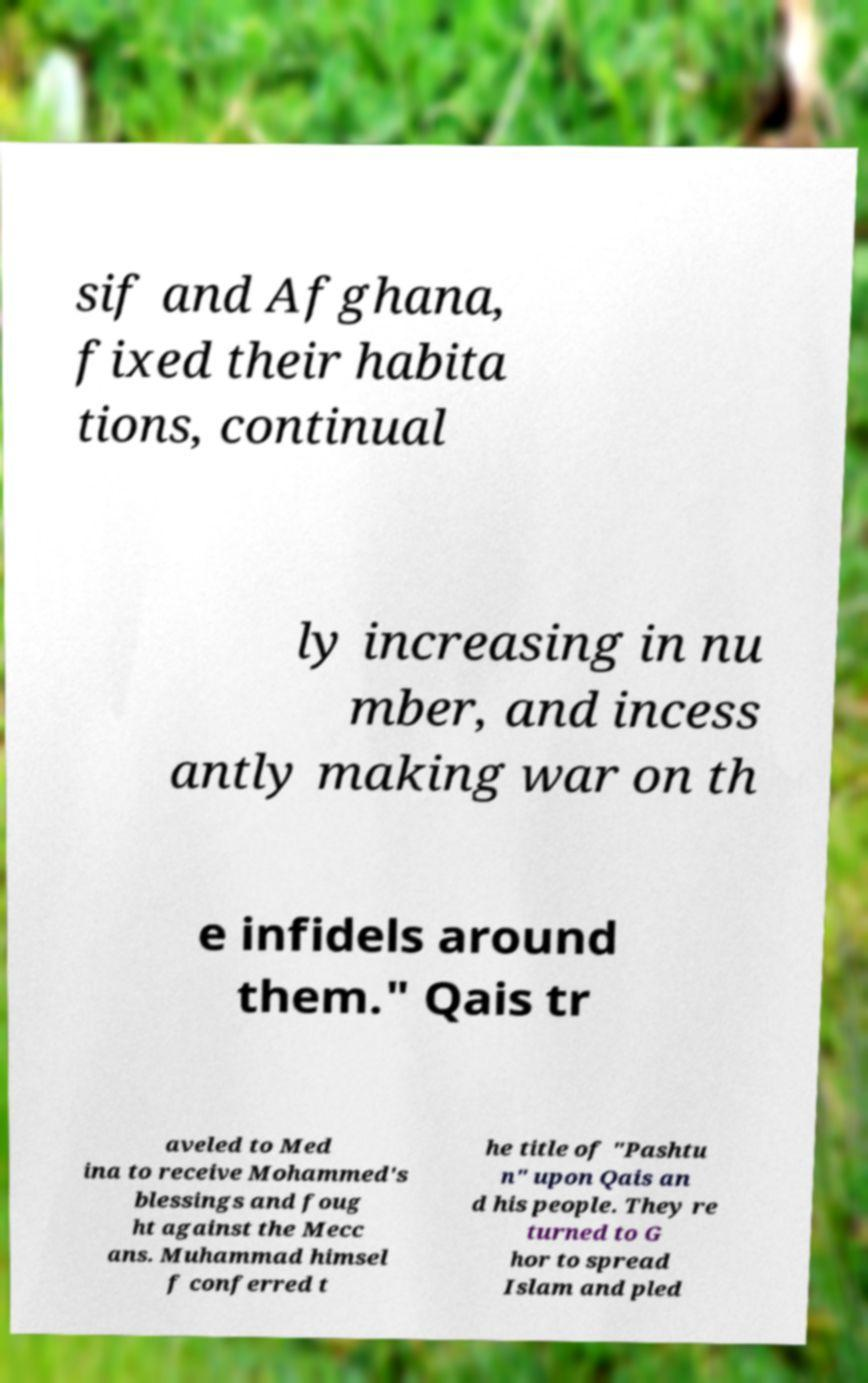For documentation purposes, I need the text within this image transcribed. Could you provide that? sif and Afghana, fixed their habita tions, continual ly increasing in nu mber, and incess antly making war on th e infidels around them." Qais tr aveled to Med ina to receive Mohammed's blessings and foug ht against the Mecc ans. Muhammad himsel f conferred t he title of "Pashtu n" upon Qais an d his people. They re turned to G hor to spread Islam and pled 